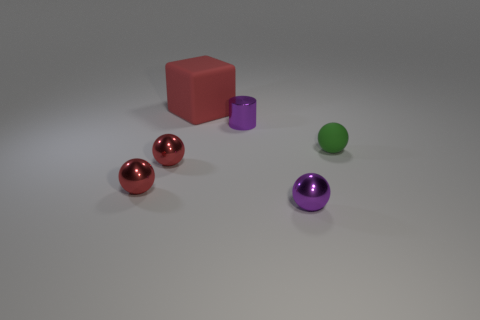Add 4 blue things. How many objects exist? 10 Subtract all balls. How many objects are left? 2 Subtract all purple metal cylinders. Subtract all tiny red spheres. How many objects are left? 3 Add 4 small rubber objects. How many small rubber objects are left? 5 Add 2 green shiny blocks. How many green shiny blocks exist? 2 Subtract 0 brown cylinders. How many objects are left? 6 